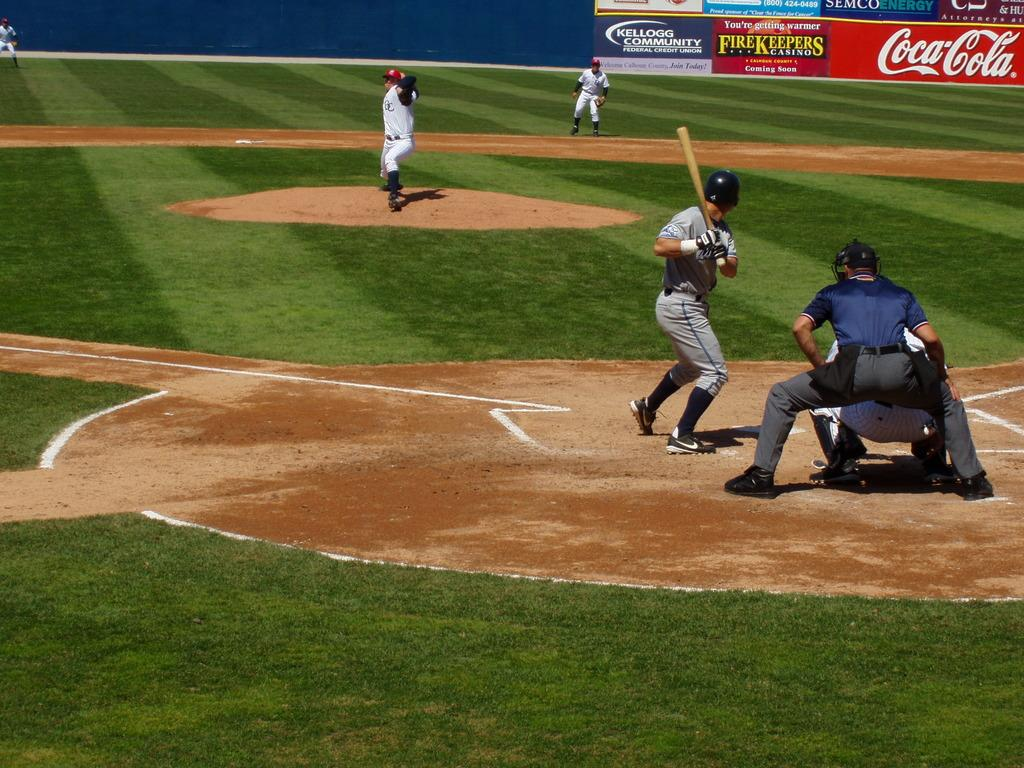<image>
Write a terse but informative summary of the picture. A sign for the FireKeepers Casino is along the edge of the baseball field. 